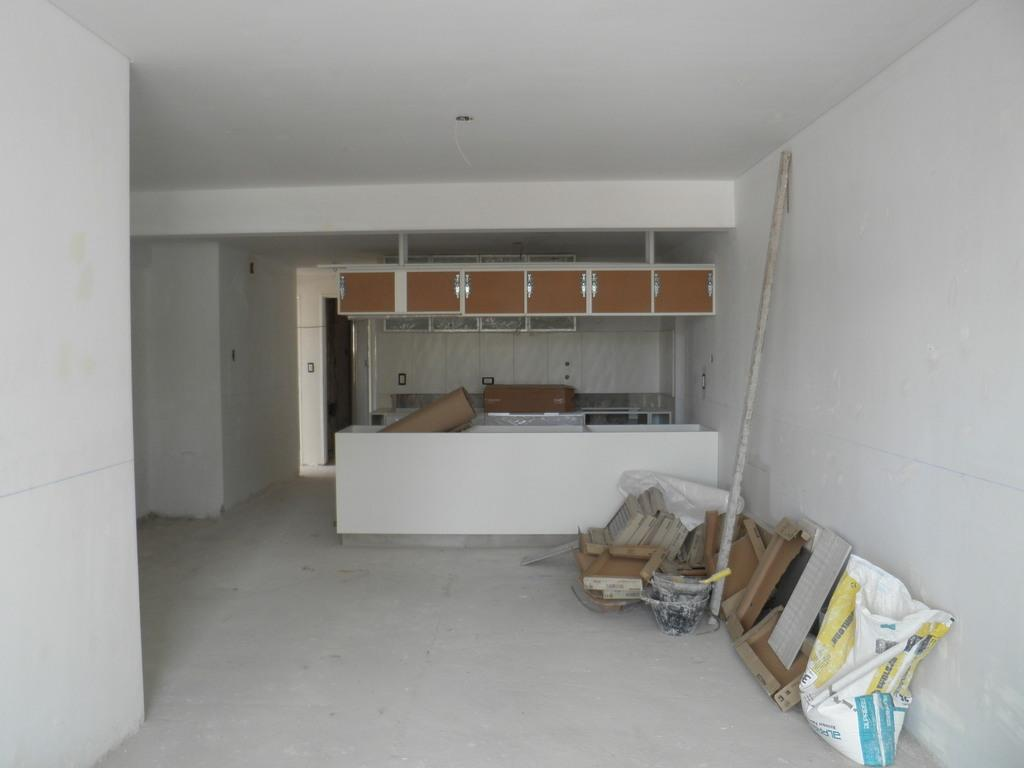What type of materials can be seen in the room in the image? There are construction materials in the room. What type of furniture can be seen in the background of the image? There are cupboards in the background of the image. Is there any blood visible on the construction materials in the image? No, there is no blood visible on the construction materials in the image. 